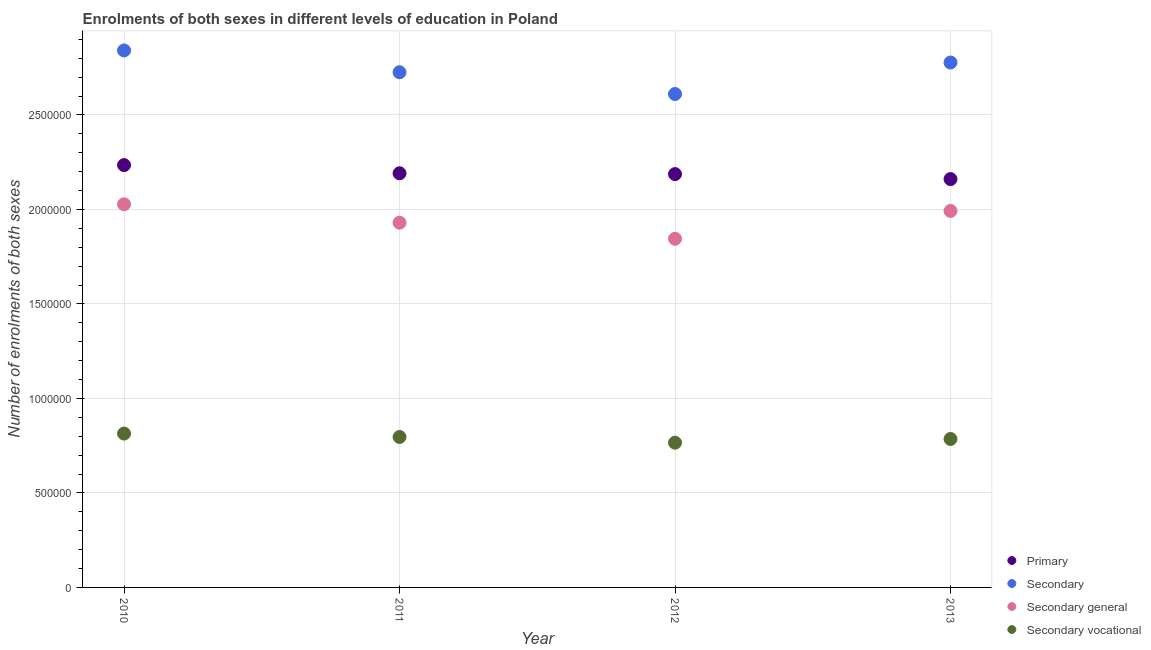How many different coloured dotlines are there?
Make the answer very short. 4. What is the number of enrolments in secondary general education in 2010?
Your answer should be very brief. 2.03e+06. Across all years, what is the maximum number of enrolments in secondary general education?
Your answer should be very brief. 2.03e+06. Across all years, what is the minimum number of enrolments in secondary vocational education?
Your answer should be compact. 7.66e+05. In which year was the number of enrolments in primary education maximum?
Your answer should be compact. 2010. What is the total number of enrolments in secondary general education in the graph?
Your answer should be very brief. 7.79e+06. What is the difference between the number of enrolments in secondary education in 2012 and that in 2013?
Keep it short and to the point. -1.67e+05. What is the difference between the number of enrolments in primary education in 2010 and the number of enrolments in secondary general education in 2012?
Provide a short and direct response. 3.90e+05. What is the average number of enrolments in primary education per year?
Provide a succinct answer. 2.19e+06. In the year 2010, what is the difference between the number of enrolments in primary education and number of enrolments in secondary education?
Provide a succinct answer. -6.07e+05. In how many years, is the number of enrolments in secondary general education greater than 2200000?
Keep it short and to the point. 0. What is the ratio of the number of enrolments in secondary general education in 2010 to that in 2012?
Keep it short and to the point. 1.1. Is the number of enrolments in secondary general education in 2010 less than that in 2012?
Give a very brief answer. No. Is the difference between the number of enrolments in secondary vocational education in 2011 and 2013 greater than the difference between the number of enrolments in secondary general education in 2011 and 2013?
Your answer should be very brief. Yes. What is the difference between the highest and the second highest number of enrolments in secondary education?
Offer a very short reply. 6.39e+04. What is the difference between the highest and the lowest number of enrolments in secondary general education?
Your answer should be compact. 1.82e+05. In how many years, is the number of enrolments in primary education greater than the average number of enrolments in primary education taken over all years?
Your response must be concise. 1. Is the sum of the number of enrolments in primary education in 2011 and 2013 greater than the maximum number of enrolments in secondary education across all years?
Your response must be concise. Yes. Is it the case that in every year, the sum of the number of enrolments in primary education and number of enrolments in secondary education is greater than the number of enrolments in secondary general education?
Offer a terse response. Yes. Is the number of enrolments in secondary vocational education strictly greater than the number of enrolments in secondary general education over the years?
Keep it short and to the point. No. Does the graph contain grids?
Give a very brief answer. Yes. How many legend labels are there?
Offer a very short reply. 4. What is the title of the graph?
Your answer should be very brief. Enrolments of both sexes in different levels of education in Poland. What is the label or title of the Y-axis?
Your answer should be very brief. Number of enrolments of both sexes. What is the Number of enrolments of both sexes of Primary in 2010?
Ensure brevity in your answer.  2.23e+06. What is the Number of enrolments of both sexes in Secondary in 2010?
Your response must be concise. 2.84e+06. What is the Number of enrolments of both sexes of Secondary general in 2010?
Your answer should be very brief. 2.03e+06. What is the Number of enrolments of both sexes in Secondary vocational in 2010?
Your answer should be very brief. 8.14e+05. What is the Number of enrolments of both sexes in Primary in 2011?
Make the answer very short. 2.19e+06. What is the Number of enrolments of both sexes of Secondary in 2011?
Ensure brevity in your answer.  2.73e+06. What is the Number of enrolments of both sexes of Secondary general in 2011?
Your response must be concise. 1.93e+06. What is the Number of enrolments of both sexes of Secondary vocational in 2011?
Your answer should be compact. 7.96e+05. What is the Number of enrolments of both sexes of Primary in 2012?
Ensure brevity in your answer.  2.19e+06. What is the Number of enrolments of both sexes in Secondary in 2012?
Provide a short and direct response. 2.61e+06. What is the Number of enrolments of both sexes of Secondary general in 2012?
Give a very brief answer. 1.85e+06. What is the Number of enrolments of both sexes in Secondary vocational in 2012?
Keep it short and to the point. 7.66e+05. What is the Number of enrolments of both sexes in Primary in 2013?
Ensure brevity in your answer.  2.16e+06. What is the Number of enrolments of both sexes in Secondary in 2013?
Offer a terse response. 2.78e+06. What is the Number of enrolments of both sexes in Secondary general in 2013?
Give a very brief answer. 1.99e+06. What is the Number of enrolments of both sexes in Secondary vocational in 2013?
Your answer should be compact. 7.86e+05. Across all years, what is the maximum Number of enrolments of both sexes in Primary?
Give a very brief answer. 2.23e+06. Across all years, what is the maximum Number of enrolments of both sexes of Secondary?
Offer a very short reply. 2.84e+06. Across all years, what is the maximum Number of enrolments of both sexes in Secondary general?
Keep it short and to the point. 2.03e+06. Across all years, what is the maximum Number of enrolments of both sexes of Secondary vocational?
Your answer should be compact. 8.14e+05. Across all years, what is the minimum Number of enrolments of both sexes in Primary?
Provide a short and direct response. 2.16e+06. Across all years, what is the minimum Number of enrolments of both sexes in Secondary?
Offer a very short reply. 2.61e+06. Across all years, what is the minimum Number of enrolments of both sexes in Secondary general?
Keep it short and to the point. 1.85e+06. Across all years, what is the minimum Number of enrolments of both sexes in Secondary vocational?
Your answer should be compact. 7.66e+05. What is the total Number of enrolments of both sexes in Primary in the graph?
Make the answer very short. 8.77e+06. What is the total Number of enrolments of both sexes of Secondary in the graph?
Provide a short and direct response. 1.10e+07. What is the total Number of enrolments of both sexes of Secondary general in the graph?
Offer a very short reply. 7.79e+06. What is the total Number of enrolments of both sexes of Secondary vocational in the graph?
Offer a terse response. 3.16e+06. What is the difference between the Number of enrolments of both sexes in Primary in 2010 and that in 2011?
Your response must be concise. 4.33e+04. What is the difference between the Number of enrolments of both sexes in Secondary in 2010 and that in 2011?
Keep it short and to the point. 1.15e+05. What is the difference between the Number of enrolments of both sexes in Secondary general in 2010 and that in 2011?
Provide a short and direct response. 9.74e+04. What is the difference between the Number of enrolments of both sexes in Secondary vocational in 2010 and that in 2011?
Ensure brevity in your answer.  1.79e+04. What is the difference between the Number of enrolments of both sexes of Primary in 2010 and that in 2012?
Offer a terse response. 4.78e+04. What is the difference between the Number of enrolments of both sexes in Secondary in 2010 and that in 2012?
Make the answer very short. 2.31e+05. What is the difference between the Number of enrolments of both sexes of Secondary general in 2010 and that in 2012?
Provide a succinct answer. 1.82e+05. What is the difference between the Number of enrolments of both sexes in Secondary vocational in 2010 and that in 2012?
Your answer should be compact. 4.81e+04. What is the difference between the Number of enrolments of both sexes in Primary in 2010 and that in 2013?
Give a very brief answer. 7.41e+04. What is the difference between the Number of enrolments of both sexes of Secondary in 2010 and that in 2013?
Provide a succinct answer. 6.39e+04. What is the difference between the Number of enrolments of both sexes in Secondary general in 2010 and that in 2013?
Provide a short and direct response. 3.54e+04. What is the difference between the Number of enrolments of both sexes of Secondary vocational in 2010 and that in 2013?
Provide a succinct answer. 2.85e+04. What is the difference between the Number of enrolments of both sexes of Primary in 2011 and that in 2012?
Your answer should be compact. 4487. What is the difference between the Number of enrolments of both sexes of Secondary in 2011 and that in 2012?
Ensure brevity in your answer.  1.15e+05. What is the difference between the Number of enrolments of both sexes in Secondary general in 2011 and that in 2012?
Offer a terse response. 8.51e+04. What is the difference between the Number of enrolments of both sexes in Secondary vocational in 2011 and that in 2012?
Give a very brief answer. 3.01e+04. What is the difference between the Number of enrolments of both sexes of Primary in 2011 and that in 2013?
Ensure brevity in your answer.  3.08e+04. What is the difference between the Number of enrolments of both sexes of Secondary in 2011 and that in 2013?
Offer a terse response. -5.14e+04. What is the difference between the Number of enrolments of both sexes of Secondary general in 2011 and that in 2013?
Your answer should be very brief. -6.20e+04. What is the difference between the Number of enrolments of both sexes in Secondary vocational in 2011 and that in 2013?
Your answer should be very brief. 1.06e+04. What is the difference between the Number of enrolments of both sexes of Primary in 2012 and that in 2013?
Your answer should be compact. 2.63e+04. What is the difference between the Number of enrolments of both sexes of Secondary in 2012 and that in 2013?
Offer a terse response. -1.67e+05. What is the difference between the Number of enrolments of both sexes of Secondary general in 2012 and that in 2013?
Offer a terse response. -1.47e+05. What is the difference between the Number of enrolments of both sexes in Secondary vocational in 2012 and that in 2013?
Provide a short and direct response. -1.96e+04. What is the difference between the Number of enrolments of both sexes in Primary in 2010 and the Number of enrolments of both sexes in Secondary in 2011?
Make the answer very short. -4.91e+05. What is the difference between the Number of enrolments of both sexes of Primary in 2010 and the Number of enrolments of both sexes of Secondary general in 2011?
Offer a terse response. 3.05e+05. What is the difference between the Number of enrolments of both sexes in Primary in 2010 and the Number of enrolments of both sexes in Secondary vocational in 2011?
Provide a succinct answer. 1.44e+06. What is the difference between the Number of enrolments of both sexes in Secondary in 2010 and the Number of enrolments of both sexes in Secondary general in 2011?
Make the answer very short. 9.11e+05. What is the difference between the Number of enrolments of both sexes in Secondary in 2010 and the Number of enrolments of both sexes in Secondary vocational in 2011?
Offer a terse response. 2.05e+06. What is the difference between the Number of enrolments of both sexes of Secondary general in 2010 and the Number of enrolments of both sexes of Secondary vocational in 2011?
Provide a short and direct response. 1.23e+06. What is the difference between the Number of enrolments of both sexes of Primary in 2010 and the Number of enrolments of both sexes of Secondary in 2012?
Offer a terse response. -3.76e+05. What is the difference between the Number of enrolments of both sexes in Primary in 2010 and the Number of enrolments of both sexes in Secondary general in 2012?
Your answer should be very brief. 3.90e+05. What is the difference between the Number of enrolments of both sexes of Primary in 2010 and the Number of enrolments of both sexes of Secondary vocational in 2012?
Provide a short and direct response. 1.47e+06. What is the difference between the Number of enrolments of both sexes of Secondary in 2010 and the Number of enrolments of both sexes of Secondary general in 2012?
Your response must be concise. 9.97e+05. What is the difference between the Number of enrolments of both sexes of Secondary in 2010 and the Number of enrolments of both sexes of Secondary vocational in 2012?
Provide a short and direct response. 2.08e+06. What is the difference between the Number of enrolments of both sexes of Secondary general in 2010 and the Number of enrolments of both sexes of Secondary vocational in 2012?
Offer a terse response. 1.26e+06. What is the difference between the Number of enrolments of both sexes of Primary in 2010 and the Number of enrolments of both sexes of Secondary in 2013?
Make the answer very short. -5.43e+05. What is the difference between the Number of enrolments of both sexes of Primary in 2010 and the Number of enrolments of both sexes of Secondary general in 2013?
Provide a short and direct response. 2.43e+05. What is the difference between the Number of enrolments of both sexes in Primary in 2010 and the Number of enrolments of both sexes in Secondary vocational in 2013?
Provide a succinct answer. 1.45e+06. What is the difference between the Number of enrolments of both sexes in Secondary in 2010 and the Number of enrolments of both sexes in Secondary general in 2013?
Provide a succinct answer. 8.49e+05. What is the difference between the Number of enrolments of both sexes of Secondary in 2010 and the Number of enrolments of both sexes of Secondary vocational in 2013?
Your response must be concise. 2.06e+06. What is the difference between the Number of enrolments of both sexes of Secondary general in 2010 and the Number of enrolments of both sexes of Secondary vocational in 2013?
Your answer should be compact. 1.24e+06. What is the difference between the Number of enrolments of both sexes in Primary in 2011 and the Number of enrolments of both sexes in Secondary in 2012?
Give a very brief answer. -4.19e+05. What is the difference between the Number of enrolments of both sexes of Primary in 2011 and the Number of enrolments of both sexes of Secondary general in 2012?
Ensure brevity in your answer.  3.47e+05. What is the difference between the Number of enrolments of both sexes of Primary in 2011 and the Number of enrolments of both sexes of Secondary vocational in 2012?
Make the answer very short. 1.43e+06. What is the difference between the Number of enrolments of both sexes of Secondary in 2011 and the Number of enrolments of both sexes of Secondary general in 2012?
Ensure brevity in your answer.  8.81e+05. What is the difference between the Number of enrolments of both sexes in Secondary in 2011 and the Number of enrolments of both sexes in Secondary vocational in 2012?
Your response must be concise. 1.96e+06. What is the difference between the Number of enrolments of both sexes of Secondary general in 2011 and the Number of enrolments of both sexes of Secondary vocational in 2012?
Provide a short and direct response. 1.16e+06. What is the difference between the Number of enrolments of both sexes of Primary in 2011 and the Number of enrolments of both sexes of Secondary in 2013?
Keep it short and to the point. -5.86e+05. What is the difference between the Number of enrolments of both sexes in Primary in 2011 and the Number of enrolments of both sexes in Secondary general in 2013?
Offer a terse response. 1.99e+05. What is the difference between the Number of enrolments of both sexes of Primary in 2011 and the Number of enrolments of both sexes of Secondary vocational in 2013?
Your answer should be very brief. 1.41e+06. What is the difference between the Number of enrolments of both sexes of Secondary in 2011 and the Number of enrolments of both sexes of Secondary general in 2013?
Your answer should be compact. 7.34e+05. What is the difference between the Number of enrolments of both sexes in Secondary in 2011 and the Number of enrolments of both sexes in Secondary vocational in 2013?
Your answer should be very brief. 1.94e+06. What is the difference between the Number of enrolments of both sexes of Secondary general in 2011 and the Number of enrolments of both sexes of Secondary vocational in 2013?
Offer a very short reply. 1.14e+06. What is the difference between the Number of enrolments of both sexes in Primary in 2012 and the Number of enrolments of both sexes in Secondary in 2013?
Your answer should be compact. -5.91e+05. What is the difference between the Number of enrolments of both sexes in Primary in 2012 and the Number of enrolments of both sexes in Secondary general in 2013?
Give a very brief answer. 1.95e+05. What is the difference between the Number of enrolments of both sexes in Primary in 2012 and the Number of enrolments of both sexes in Secondary vocational in 2013?
Make the answer very short. 1.40e+06. What is the difference between the Number of enrolments of both sexes in Secondary in 2012 and the Number of enrolments of both sexes in Secondary general in 2013?
Make the answer very short. 6.19e+05. What is the difference between the Number of enrolments of both sexes in Secondary in 2012 and the Number of enrolments of both sexes in Secondary vocational in 2013?
Keep it short and to the point. 1.83e+06. What is the difference between the Number of enrolments of both sexes of Secondary general in 2012 and the Number of enrolments of both sexes of Secondary vocational in 2013?
Provide a short and direct response. 1.06e+06. What is the average Number of enrolments of both sexes in Primary per year?
Make the answer very short. 2.19e+06. What is the average Number of enrolments of both sexes in Secondary per year?
Keep it short and to the point. 2.74e+06. What is the average Number of enrolments of both sexes in Secondary general per year?
Provide a short and direct response. 1.95e+06. What is the average Number of enrolments of both sexes in Secondary vocational per year?
Provide a short and direct response. 7.90e+05. In the year 2010, what is the difference between the Number of enrolments of both sexes in Primary and Number of enrolments of both sexes in Secondary?
Give a very brief answer. -6.07e+05. In the year 2010, what is the difference between the Number of enrolments of both sexes of Primary and Number of enrolments of both sexes of Secondary general?
Offer a terse response. 2.07e+05. In the year 2010, what is the difference between the Number of enrolments of both sexes of Primary and Number of enrolments of both sexes of Secondary vocational?
Give a very brief answer. 1.42e+06. In the year 2010, what is the difference between the Number of enrolments of both sexes in Secondary and Number of enrolments of both sexes in Secondary general?
Provide a short and direct response. 8.14e+05. In the year 2010, what is the difference between the Number of enrolments of both sexes of Secondary and Number of enrolments of both sexes of Secondary vocational?
Keep it short and to the point. 2.03e+06. In the year 2010, what is the difference between the Number of enrolments of both sexes of Secondary general and Number of enrolments of both sexes of Secondary vocational?
Keep it short and to the point. 1.21e+06. In the year 2011, what is the difference between the Number of enrolments of both sexes in Primary and Number of enrolments of both sexes in Secondary?
Offer a terse response. -5.35e+05. In the year 2011, what is the difference between the Number of enrolments of both sexes of Primary and Number of enrolments of both sexes of Secondary general?
Provide a succinct answer. 2.62e+05. In the year 2011, what is the difference between the Number of enrolments of both sexes in Primary and Number of enrolments of both sexes in Secondary vocational?
Make the answer very short. 1.40e+06. In the year 2011, what is the difference between the Number of enrolments of both sexes in Secondary and Number of enrolments of both sexes in Secondary general?
Your answer should be compact. 7.96e+05. In the year 2011, what is the difference between the Number of enrolments of both sexes in Secondary and Number of enrolments of both sexes in Secondary vocational?
Your answer should be very brief. 1.93e+06. In the year 2011, what is the difference between the Number of enrolments of both sexes of Secondary general and Number of enrolments of both sexes of Secondary vocational?
Give a very brief answer. 1.13e+06. In the year 2012, what is the difference between the Number of enrolments of both sexes of Primary and Number of enrolments of both sexes of Secondary?
Offer a terse response. -4.24e+05. In the year 2012, what is the difference between the Number of enrolments of both sexes in Primary and Number of enrolments of both sexes in Secondary general?
Your answer should be very brief. 3.42e+05. In the year 2012, what is the difference between the Number of enrolments of both sexes in Primary and Number of enrolments of both sexes in Secondary vocational?
Offer a terse response. 1.42e+06. In the year 2012, what is the difference between the Number of enrolments of both sexes of Secondary and Number of enrolments of both sexes of Secondary general?
Your answer should be compact. 7.66e+05. In the year 2012, what is the difference between the Number of enrolments of both sexes of Secondary and Number of enrolments of both sexes of Secondary vocational?
Offer a terse response. 1.85e+06. In the year 2012, what is the difference between the Number of enrolments of both sexes in Secondary general and Number of enrolments of both sexes in Secondary vocational?
Ensure brevity in your answer.  1.08e+06. In the year 2013, what is the difference between the Number of enrolments of both sexes in Primary and Number of enrolments of both sexes in Secondary?
Your answer should be very brief. -6.17e+05. In the year 2013, what is the difference between the Number of enrolments of both sexes of Primary and Number of enrolments of both sexes of Secondary general?
Make the answer very short. 1.69e+05. In the year 2013, what is the difference between the Number of enrolments of both sexes of Primary and Number of enrolments of both sexes of Secondary vocational?
Make the answer very short. 1.38e+06. In the year 2013, what is the difference between the Number of enrolments of both sexes in Secondary and Number of enrolments of both sexes in Secondary general?
Ensure brevity in your answer.  7.86e+05. In the year 2013, what is the difference between the Number of enrolments of both sexes of Secondary and Number of enrolments of both sexes of Secondary vocational?
Keep it short and to the point. 1.99e+06. In the year 2013, what is the difference between the Number of enrolments of both sexes in Secondary general and Number of enrolments of both sexes in Secondary vocational?
Your answer should be very brief. 1.21e+06. What is the ratio of the Number of enrolments of both sexes of Primary in 2010 to that in 2011?
Keep it short and to the point. 1.02. What is the ratio of the Number of enrolments of both sexes in Secondary in 2010 to that in 2011?
Your response must be concise. 1.04. What is the ratio of the Number of enrolments of both sexes of Secondary general in 2010 to that in 2011?
Offer a very short reply. 1.05. What is the ratio of the Number of enrolments of both sexes in Secondary vocational in 2010 to that in 2011?
Make the answer very short. 1.02. What is the ratio of the Number of enrolments of both sexes in Primary in 2010 to that in 2012?
Make the answer very short. 1.02. What is the ratio of the Number of enrolments of both sexes in Secondary in 2010 to that in 2012?
Give a very brief answer. 1.09. What is the ratio of the Number of enrolments of both sexes in Secondary general in 2010 to that in 2012?
Provide a short and direct response. 1.1. What is the ratio of the Number of enrolments of both sexes in Secondary vocational in 2010 to that in 2012?
Keep it short and to the point. 1.06. What is the ratio of the Number of enrolments of both sexes of Primary in 2010 to that in 2013?
Offer a terse response. 1.03. What is the ratio of the Number of enrolments of both sexes of Secondary general in 2010 to that in 2013?
Offer a very short reply. 1.02. What is the ratio of the Number of enrolments of both sexes of Secondary vocational in 2010 to that in 2013?
Provide a short and direct response. 1.04. What is the ratio of the Number of enrolments of both sexes in Secondary in 2011 to that in 2012?
Give a very brief answer. 1.04. What is the ratio of the Number of enrolments of both sexes of Secondary general in 2011 to that in 2012?
Offer a terse response. 1.05. What is the ratio of the Number of enrolments of both sexes of Secondary vocational in 2011 to that in 2012?
Provide a succinct answer. 1.04. What is the ratio of the Number of enrolments of both sexes of Primary in 2011 to that in 2013?
Keep it short and to the point. 1.01. What is the ratio of the Number of enrolments of both sexes in Secondary in 2011 to that in 2013?
Provide a succinct answer. 0.98. What is the ratio of the Number of enrolments of both sexes in Secondary general in 2011 to that in 2013?
Offer a very short reply. 0.97. What is the ratio of the Number of enrolments of both sexes of Secondary vocational in 2011 to that in 2013?
Provide a short and direct response. 1.01. What is the ratio of the Number of enrolments of both sexes of Primary in 2012 to that in 2013?
Ensure brevity in your answer.  1.01. What is the ratio of the Number of enrolments of both sexes in Secondary general in 2012 to that in 2013?
Offer a very short reply. 0.93. What is the ratio of the Number of enrolments of both sexes in Secondary vocational in 2012 to that in 2013?
Your answer should be very brief. 0.98. What is the difference between the highest and the second highest Number of enrolments of both sexes of Primary?
Give a very brief answer. 4.33e+04. What is the difference between the highest and the second highest Number of enrolments of both sexes in Secondary?
Provide a succinct answer. 6.39e+04. What is the difference between the highest and the second highest Number of enrolments of both sexes of Secondary general?
Your response must be concise. 3.54e+04. What is the difference between the highest and the second highest Number of enrolments of both sexes of Secondary vocational?
Keep it short and to the point. 1.79e+04. What is the difference between the highest and the lowest Number of enrolments of both sexes in Primary?
Make the answer very short. 7.41e+04. What is the difference between the highest and the lowest Number of enrolments of both sexes of Secondary?
Offer a terse response. 2.31e+05. What is the difference between the highest and the lowest Number of enrolments of both sexes in Secondary general?
Your answer should be compact. 1.82e+05. What is the difference between the highest and the lowest Number of enrolments of both sexes of Secondary vocational?
Ensure brevity in your answer.  4.81e+04. 